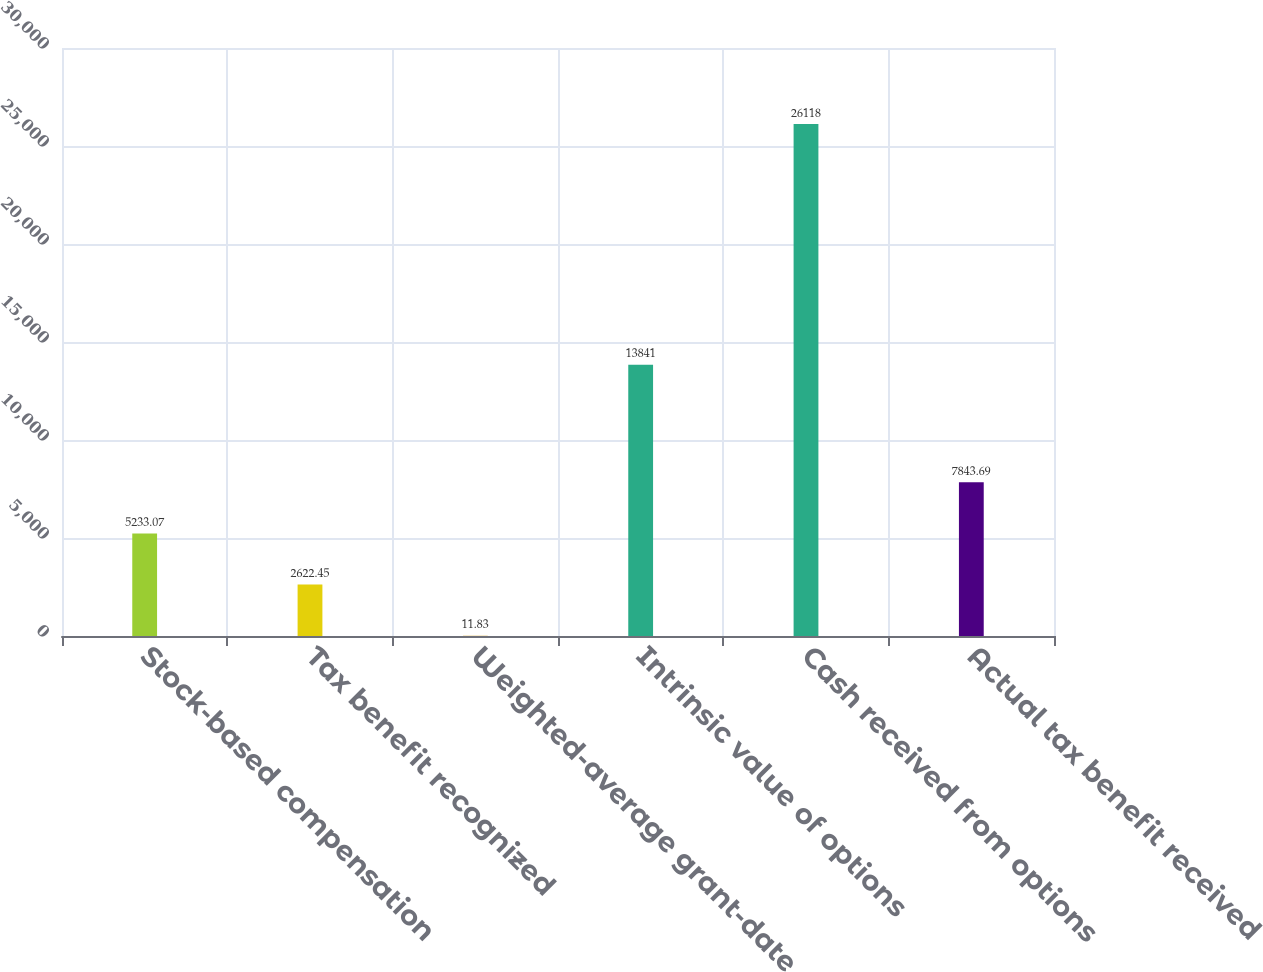Convert chart. <chart><loc_0><loc_0><loc_500><loc_500><bar_chart><fcel>Stock-based compensation<fcel>Tax benefit recognized<fcel>Weighted-average grant-date<fcel>Intrinsic value of options<fcel>Cash received from options<fcel>Actual tax benefit received<nl><fcel>5233.07<fcel>2622.45<fcel>11.83<fcel>13841<fcel>26118<fcel>7843.69<nl></chart> 